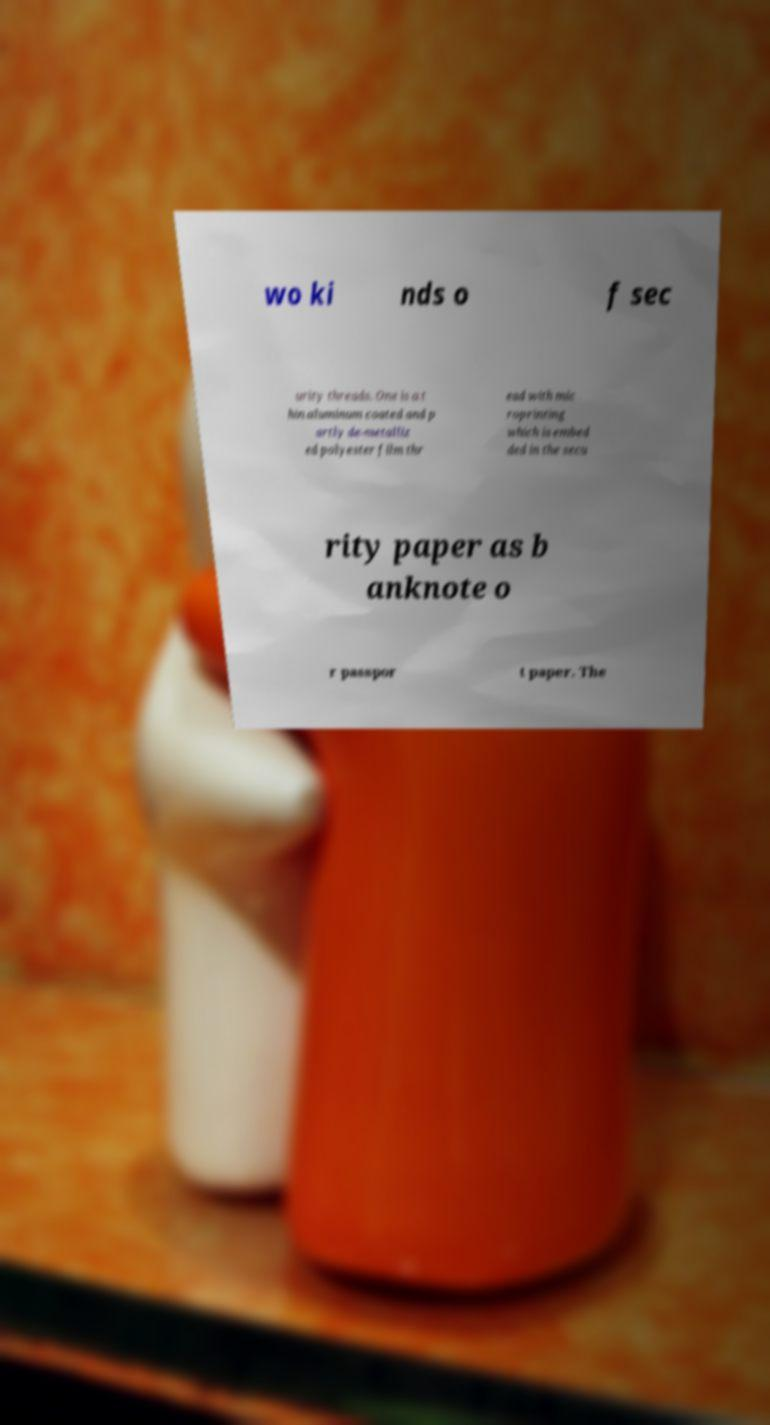Please read and relay the text visible in this image. What does it say? wo ki nds o f sec urity threads. One is a t hin aluminum coated and p artly de-metalliz ed polyester film thr ead with mic roprinting which is embed ded in the secu rity paper as b anknote o r passpor t paper. The 